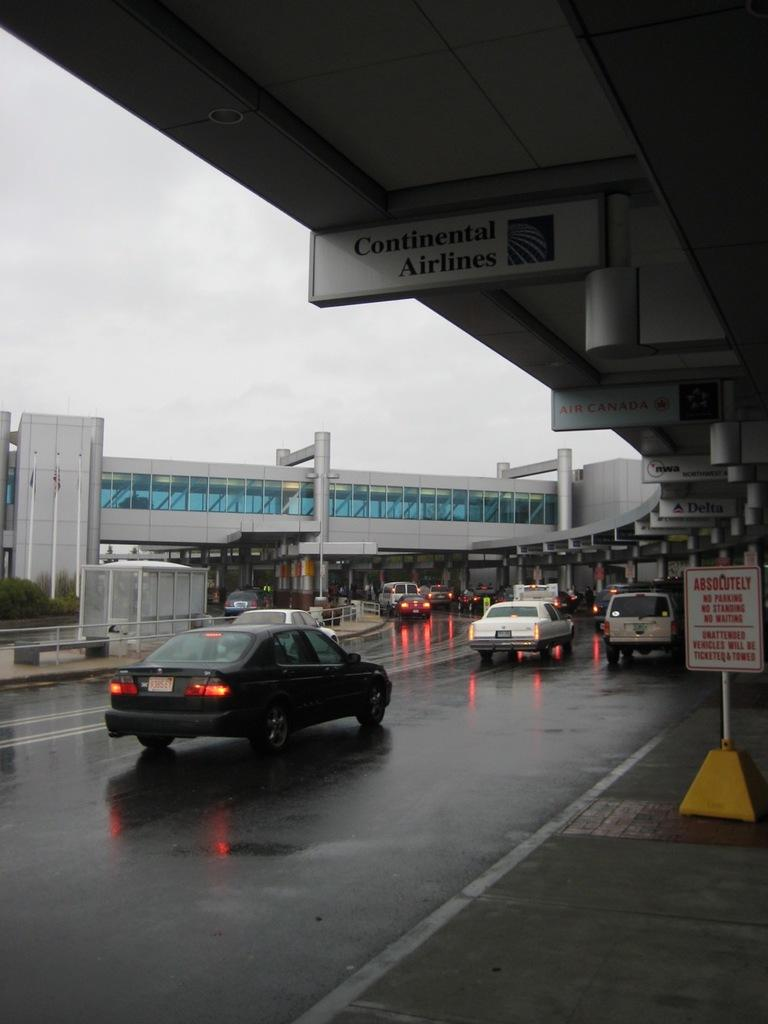What is the main feature of the image? There is a road in the image. What is happening on the road? Cars and vehicles are present on the road. What type of location does the image depict? The image appears to depict an airport. What can be seen on the footpath on the right side of the image? There is a board on the footpath on the right side of the image. What is visible at the top of the image? The sky is visible at the top of the image. What time does the watch on the airport sign indicate in the image? There is no watch present in the image. What type of tin is being used to store the luggage in the image? There is no tin present in the image; luggage is not stored in tins. 